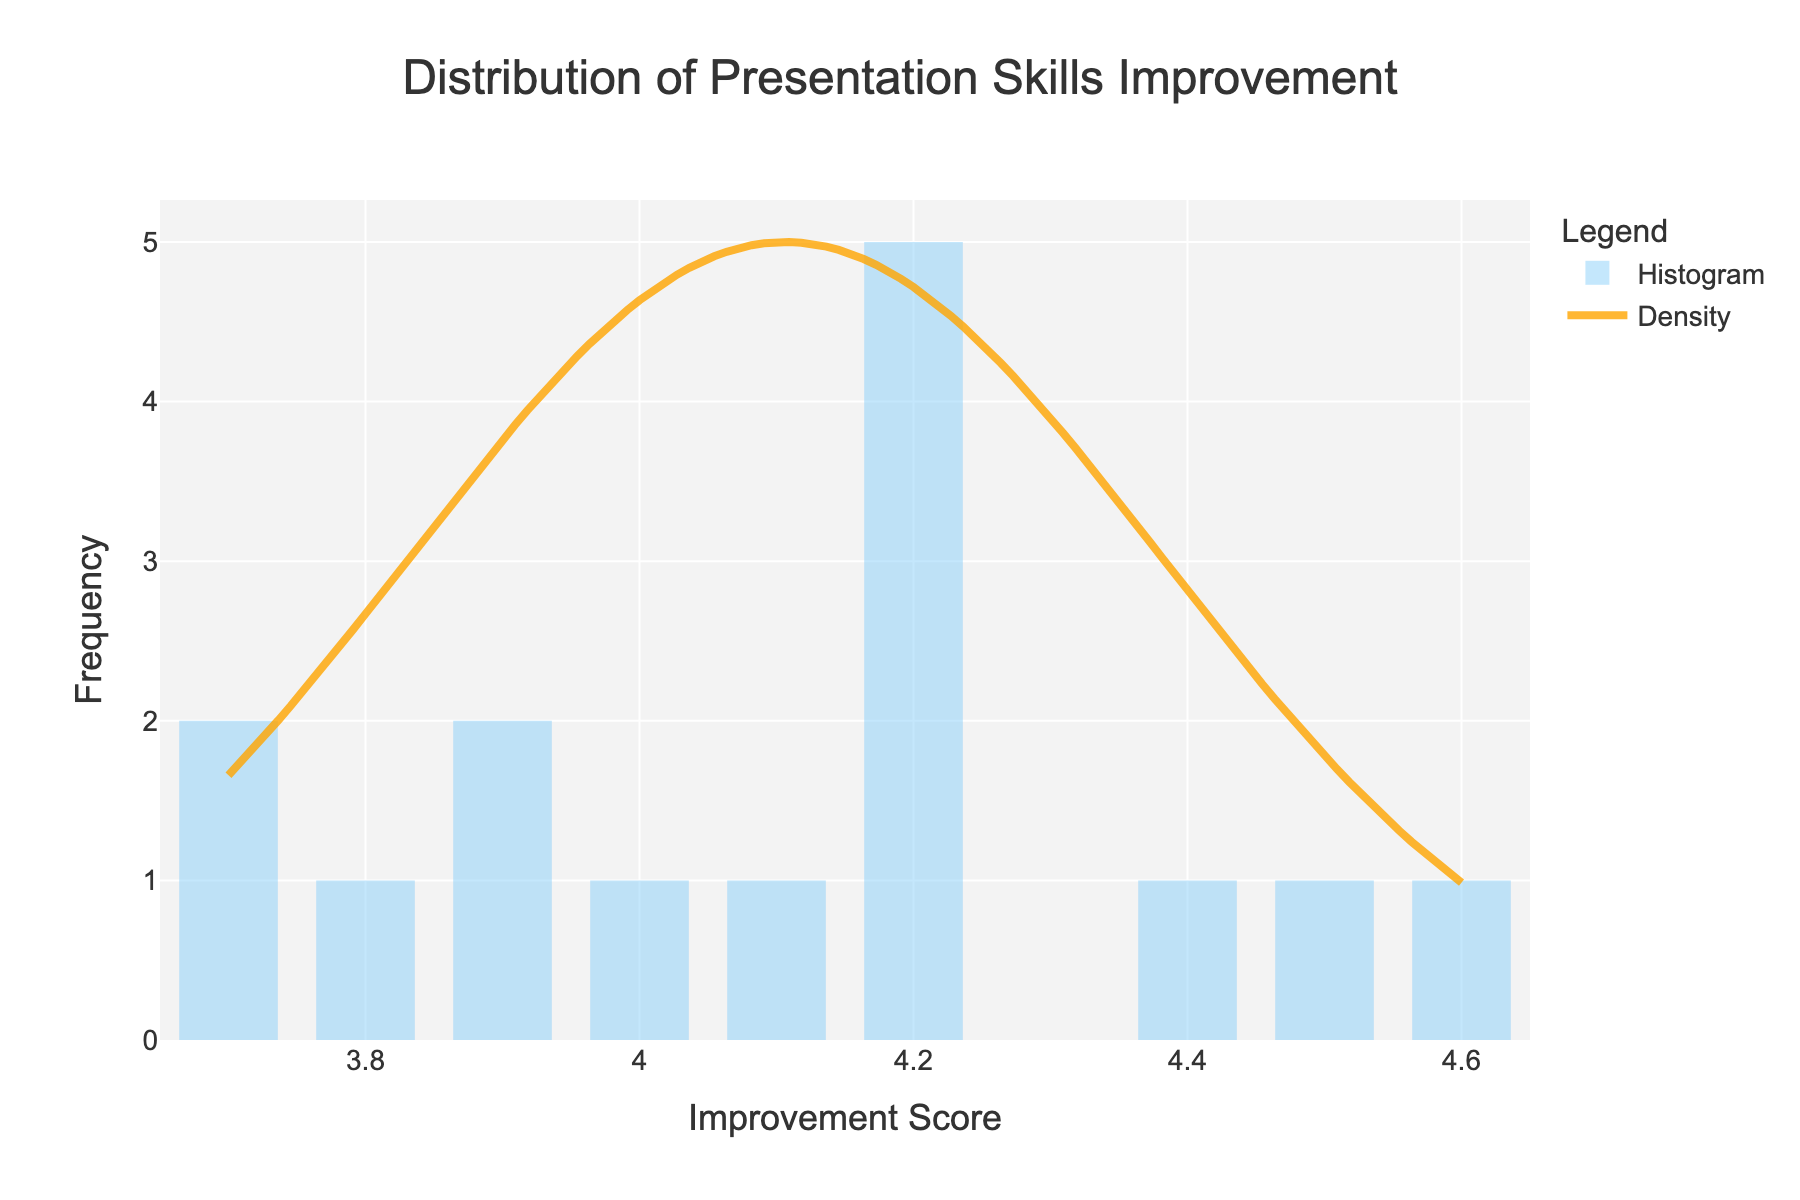What is the title of the plot? The title of the plot is prominently displayed at the top center of the figure. It reads "Distribution of Presentation Skills Improvement."
Answer: Distribution of Presentation Skills Improvement What does the x-axis represent? The x-axis title is given in the figure, and it represents "Improvement Score."
Answer: Improvement Score What color is the histogram displayed in? The histogram bars are displayed in a light blue color, specifically sky blue.
Answer: Sky blue What color is the KDE line? The KDE line is displayed in a distinct orange color.
Answer: Orange How many bins are there in the histogram? By counting the visible number of bins in the histogram, we see that there are 10 bins.
Answer: 10 What range of improvement scores have the highest frequency according to the histogram? The highest histogram bars indicate that scores around 4.2-4.4 have the highest frequency.
Answer: 4.2-4.4 Is the KDE peak aligned with the highest histogram bars? By visually inspecting the KDE line and the highest histogram bars, we can see that the KDE peak aligns with the highest histogram bars around the scores of 4.2-4.4.
Answer: Yes What seems to be the most common improvement score range from the histogram? By observing the tallest histogram bars, the most common improvement score range appears to be between 4 and 4.5.
Answer: Between 4 and 4.5 Does the histogram demonstrate a normal distribution? By examining the shape of the histogram and the KDE curve, the data seems to roughly follow a normal distribution, indicated by the bell-shaped curve of the KDE.
Answer: Roughly follows normal distribution What is the y-axis title? The title of the y-axis is given in the figure and it represents "Frequency."
Answer: Frequency 